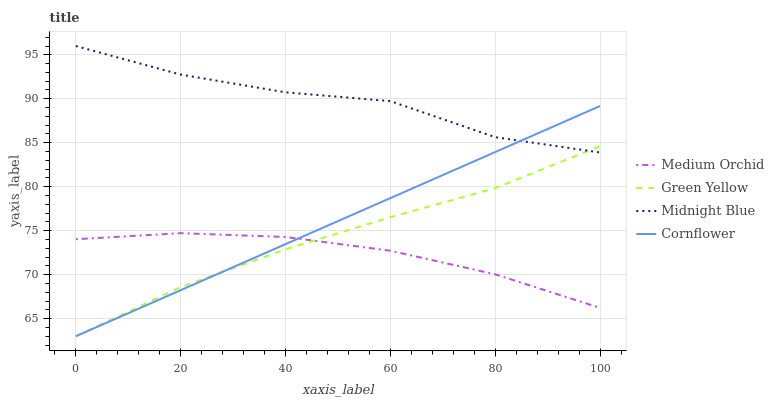Does Medium Orchid have the minimum area under the curve?
Answer yes or no. Yes. Does Midnight Blue have the maximum area under the curve?
Answer yes or no. Yes. Does Green Yellow have the minimum area under the curve?
Answer yes or no. No. Does Green Yellow have the maximum area under the curve?
Answer yes or no. No. Is Cornflower the smoothest?
Answer yes or no. Yes. Is Midnight Blue the roughest?
Answer yes or no. Yes. Is Green Yellow the smoothest?
Answer yes or no. No. Is Green Yellow the roughest?
Answer yes or no. No. Does Cornflower have the lowest value?
Answer yes or no. Yes. Does Medium Orchid have the lowest value?
Answer yes or no. No. Does Midnight Blue have the highest value?
Answer yes or no. Yes. Does Green Yellow have the highest value?
Answer yes or no. No. Is Medium Orchid less than Midnight Blue?
Answer yes or no. Yes. Is Midnight Blue greater than Medium Orchid?
Answer yes or no. Yes. Does Cornflower intersect Medium Orchid?
Answer yes or no. Yes. Is Cornflower less than Medium Orchid?
Answer yes or no. No. Is Cornflower greater than Medium Orchid?
Answer yes or no. No. Does Medium Orchid intersect Midnight Blue?
Answer yes or no. No. 